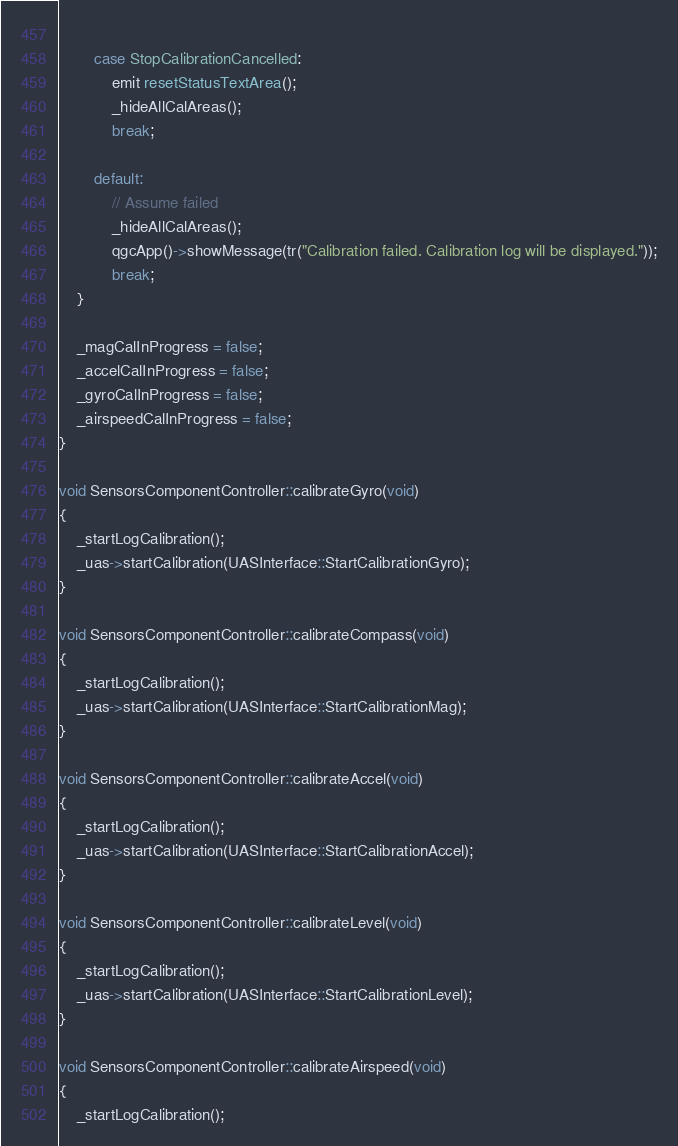Convert code to text. <code><loc_0><loc_0><loc_500><loc_500><_C++_>            
        case StopCalibrationCancelled:
            emit resetStatusTextArea();
            _hideAllCalAreas();
            break;
            
        default:
            // Assume failed
            _hideAllCalAreas();
            qgcApp()->showMessage(tr("Calibration failed. Calibration log will be displayed."));
            break;
    }
    
    _magCalInProgress = false;
    _accelCalInProgress = false;
    _gyroCalInProgress = false;
    _airspeedCalInProgress = false;
}

void SensorsComponentController::calibrateGyro(void)
{
    _startLogCalibration();
    _uas->startCalibration(UASInterface::StartCalibrationGyro);
}

void SensorsComponentController::calibrateCompass(void)
{
    _startLogCalibration();
    _uas->startCalibration(UASInterface::StartCalibrationMag);
}

void SensorsComponentController::calibrateAccel(void)
{
    _startLogCalibration();
    _uas->startCalibration(UASInterface::StartCalibrationAccel);
}

void SensorsComponentController::calibrateLevel(void)
{
    _startLogCalibration();
    _uas->startCalibration(UASInterface::StartCalibrationLevel);
}

void SensorsComponentController::calibrateAirspeed(void)
{
    _startLogCalibration();</code> 